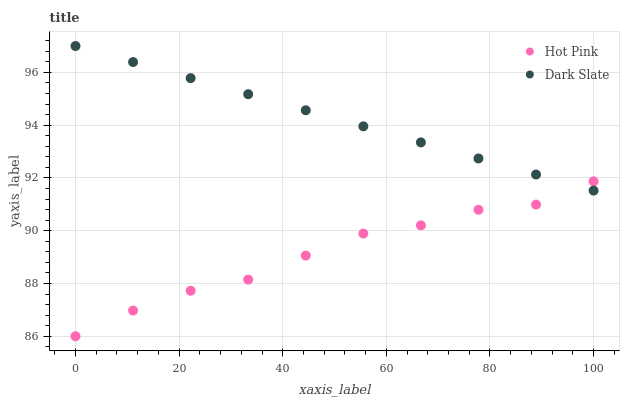Does Hot Pink have the minimum area under the curve?
Answer yes or no. Yes. Does Dark Slate have the maximum area under the curve?
Answer yes or no. Yes. Does Hot Pink have the maximum area under the curve?
Answer yes or no. No. Is Dark Slate the smoothest?
Answer yes or no. Yes. Is Hot Pink the roughest?
Answer yes or no. Yes. Is Hot Pink the smoothest?
Answer yes or no. No. Does Hot Pink have the lowest value?
Answer yes or no. Yes. Does Dark Slate have the highest value?
Answer yes or no. Yes. Does Hot Pink have the highest value?
Answer yes or no. No. Does Hot Pink intersect Dark Slate?
Answer yes or no. Yes. Is Hot Pink less than Dark Slate?
Answer yes or no. No. Is Hot Pink greater than Dark Slate?
Answer yes or no. No. 